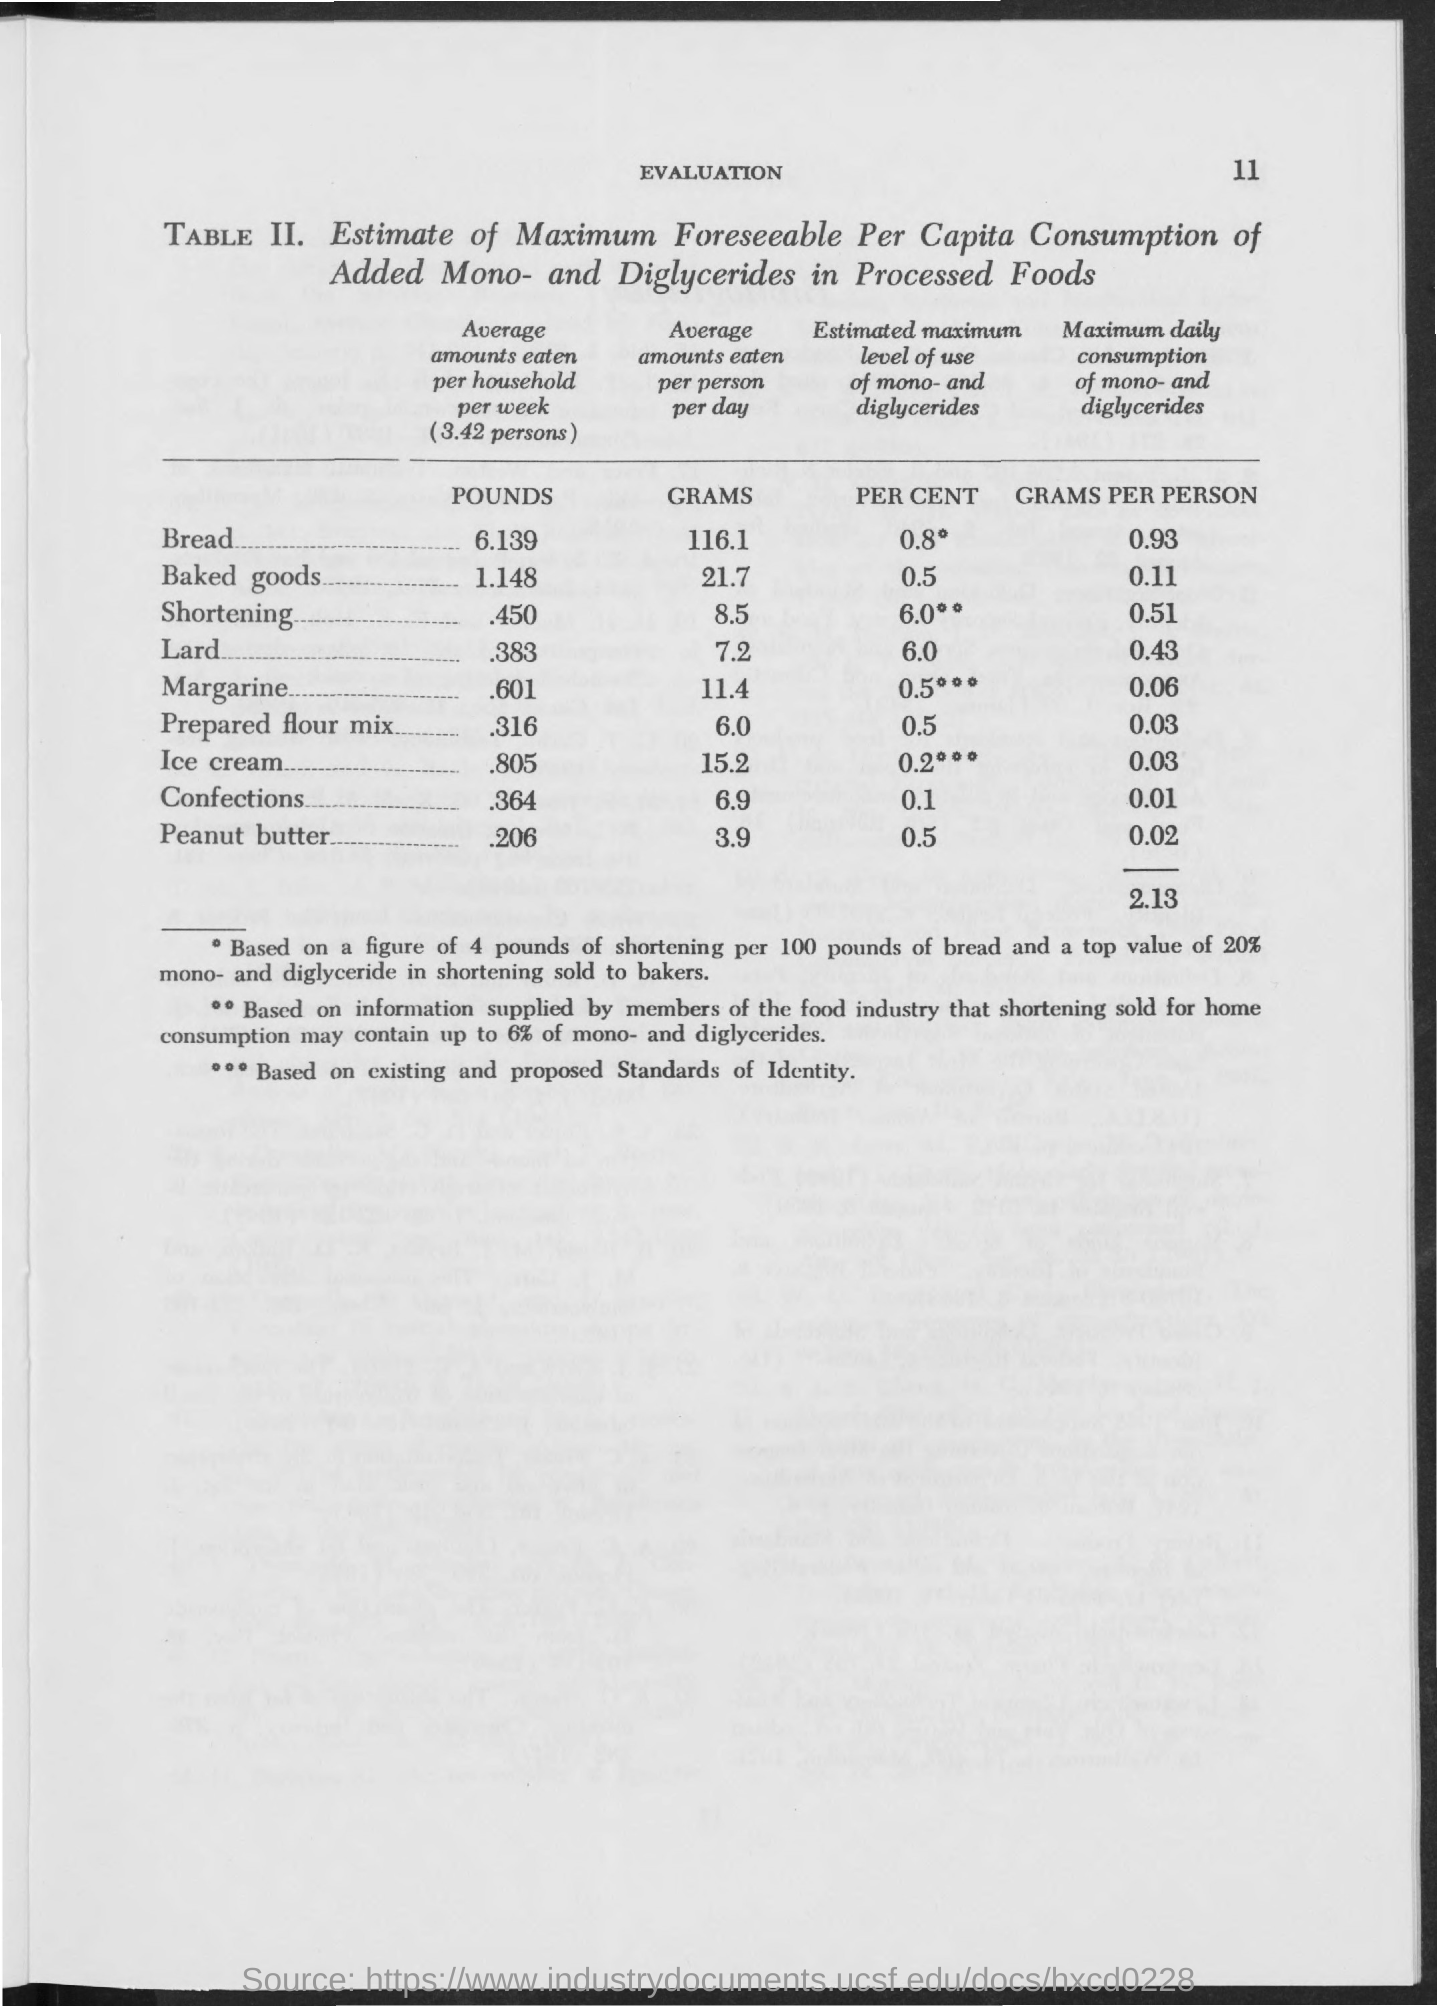Highlight a few significant elements in this photo. The first title in the document is 'Evaluation of the Document'. 